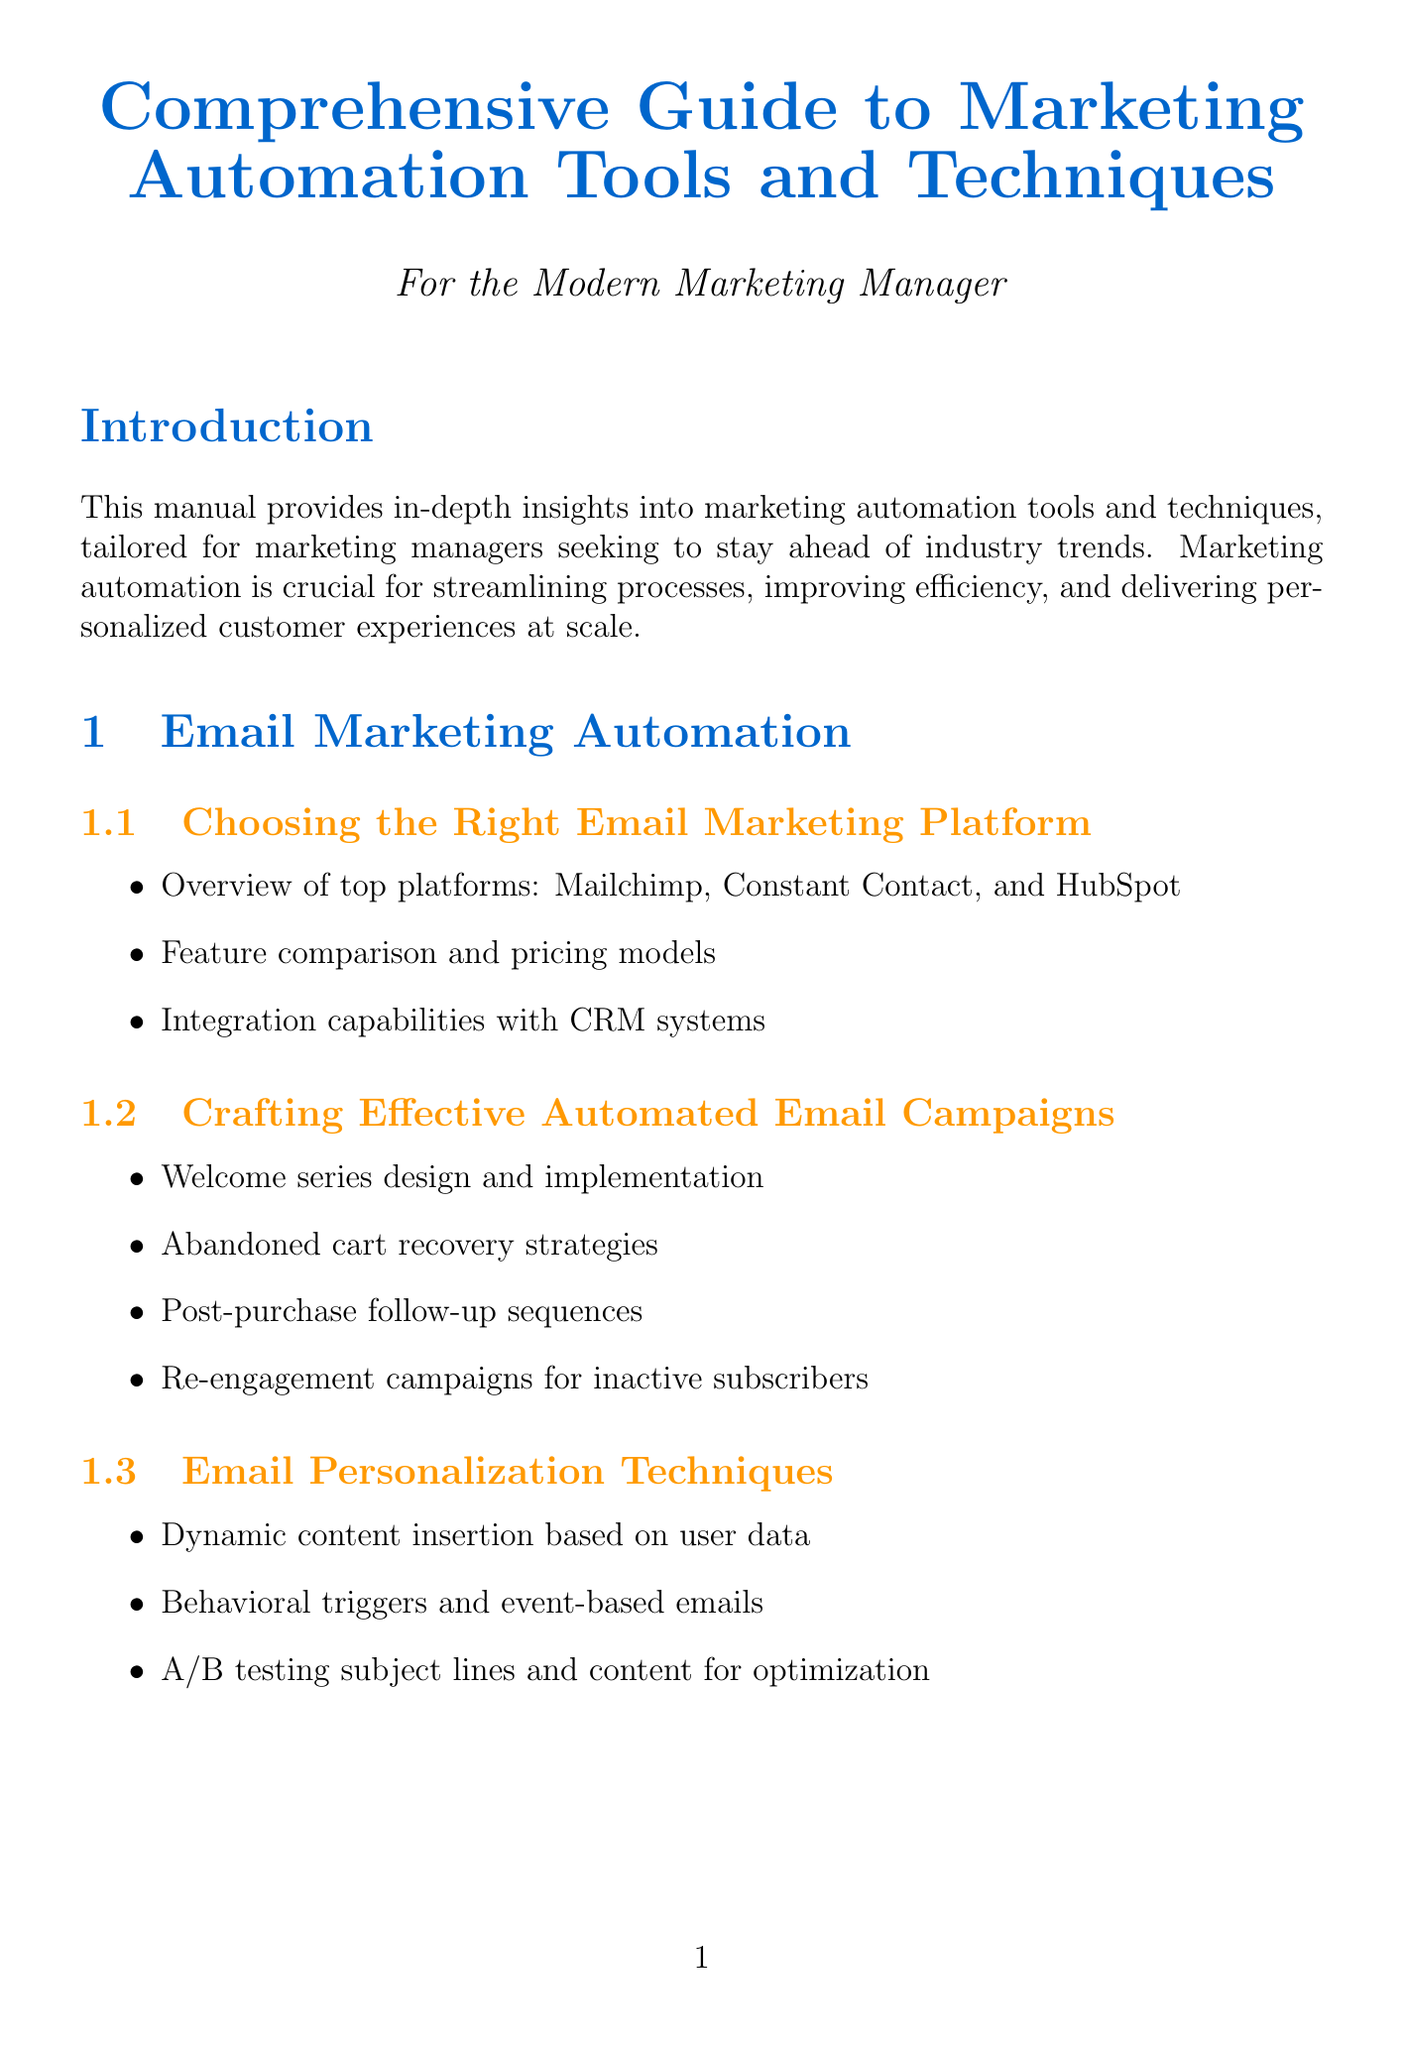What is the title of the manual? The title is mentioned at the beginning of the document, indicating the subject matter covered.
Answer: Comprehensive Guide to Marketing Automation Tools and Techniques Which email marketing platform is mentioned first in the overview? The document lists top platforms under the section for choosing the right email marketing platform, with one being listed first.
Answer: Mailchimp What is one strategy mentioned for abandoned cart recovery? The manual outlines various strategies for automated email campaigns, including one specific to abandoned cart recovery.
Answer: Abandoned cart recovery strategies Which tool is suggested for creating buyer personas? The document provides a specific tool under the section for mapping the customer journey that aids in creating buyer personas.
Answer: Xtensio What is a key performance indicator mentioned for email engagement? The section on KPIs lists specific metrics to track email engagement, highlighting various indicators related to it.
Answer: Open rates What type of segmentation uses Salesforce Marketing Cloud? The document categorizes segmentation strategies, specifying which tool is used for demographic segmentation.
Answer: Demographic segmentation Which tool is recommended for A/B testing landing pages? The manual identifies a specific tool under conversion rate optimization used for A/B testing purposes.
Answer: Optimizely What is the focus of the conclusion section? The conclusion summarizes the manual’s main emphasis, reflecting on the overall benefits of mastering the covered tools and techniques.
Answer: Drive efficiency, improve customer engagement, and demonstrate clear ROI on marketing efforts 